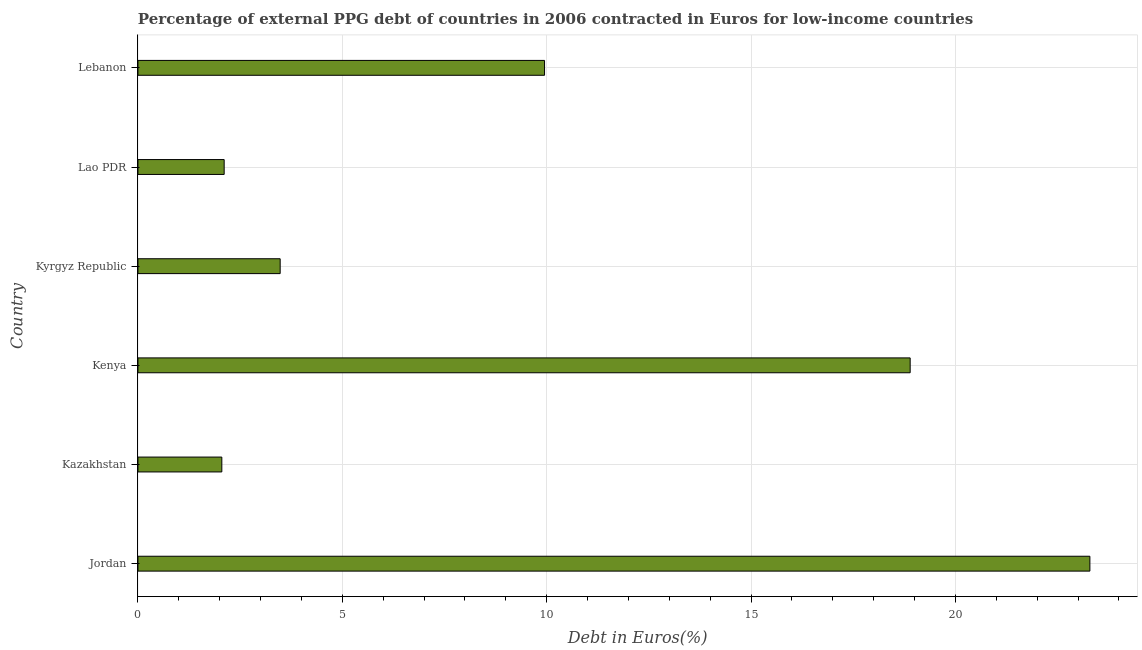Does the graph contain any zero values?
Provide a short and direct response. No. Does the graph contain grids?
Your answer should be compact. Yes. What is the title of the graph?
Keep it short and to the point. Percentage of external PPG debt of countries in 2006 contracted in Euros for low-income countries. What is the label or title of the X-axis?
Provide a succinct answer. Debt in Euros(%). What is the label or title of the Y-axis?
Make the answer very short. Country. What is the currency composition of ppg debt in Kenya?
Your response must be concise. 18.89. Across all countries, what is the maximum currency composition of ppg debt?
Offer a very short reply. 23.29. Across all countries, what is the minimum currency composition of ppg debt?
Offer a terse response. 2.05. In which country was the currency composition of ppg debt maximum?
Give a very brief answer. Jordan. In which country was the currency composition of ppg debt minimum?
Give a very brief answer. Kazakhstan. What is the sum of the currency composition of ppg debt?
Provide a short and direct response. 59.77. What is the difference between the currency composition of ppg debt in Jordan and Kyrgyz Republic?
Provide a short and direct response. 19.81. What is the average currency composition of ppg debt per country?
Make the answer very short. 9.96. What is the median currency composition of ppg debt?
Your answer should be very brief. 6.71. In how many countries, is the currency composition of ppg debt greater than 8 %?
Your answer should be very brief. 3. What is the ratio of the currency composition of ppg debt in Jordan to that in Kyrgyz Republic?
Provide a succinct answer. 6.69. Is the currency composition of ppg debt in Jordan less than that in Kyrgyz Republic?
Offer a terse response. No. What is the difference between the highest and the second highest currency composition of ppg debt?
Your response must be concise. 4.4. What is the difference between the highest and the lowest currency composition of ppg debt?
Offer a terse response. 21.24. Are all the bars in the graph horizontal?
Offer a very short reply. Yes. Are the values on the major ticks of X-axis written in scientific E-notation?
Offer a very short reply. No. What is the Debt in Euros(%) in Jordan?
Give a very brief answer. 23.29. What is the Debt in Euros(%) of Kazakhstan?
Offer a very short reply. 2.05. What is the Debt in Euros(%) in Kenya?
Your response must be concise. 18.89. What is the Debt in Euros(%) in Kyrgyz Republic?
Keep it short and to the point. 3.48. What is the Debt in Euros(%) in Lao PDR?
Your answer should be compact. 2.11. What is the Debt in Euros(%) of Lebanon?
Your answer should be compact. 9.95. What is the difference between the Debt in Euros(%) in Jordan and Kazakhstan?
Provide a succinct answer. 21.24. What is the difference between the Debt in Euros(%) in Jordan and Kenya?
Give a very brief answer. 4.4. What is the difference between the Debt in Euros(%) in Jordan and Kyrgyz Republic?
Keep it short and to the point. 19.81. What is the difference between the Debt in Euros(%) in Jordan and Lao PDR?
Keep it short and to the point. 21.18. What is the difference between the Debt in Euros(%) in Jordan and Lebanon?
Offer a very short reply. 13.34. What is the difference between the Debt in Euros(%) in Kazakhstan and Kenya?
Keep it short and to the point. -16.84. What is the difference between the Debt in Euros(%) in Kazakhstan and Kyrgyz Republic?
Your answer should be compact. -1.43. What is the difference between the Debt in Euros(%) in Kazakhstan and Lao PDR?
Make the answer very short. -0.06. What is the difference between the Debt in Euros(%) in Kazakhstan and Lebanon?
Keep it short and to the point. -7.9. What is the difference between the Debt in Euros(%) in Kenya and Kyrgyz Republic?
Your answer should be compact. 15.41. What is the difference between the Debt in Euros(%) in Kenya and Lao PDR?
Provide a short and direct response. 16.78. What is the difference between the Debt in Euros(%) in Kenya and Lebanon?
Give a very brief answer. 8.94. What is the difference between the Debt in Euros(%) in Kyrgyz Republic and Lao PDR?
Provide a short and direct response. 1.37. What is the difference between the Debt in Euros(%) in Kyrgyz Republic and Lebanon?
Provide a short and direct response. -6.47. What is the difference between the Debt in Euros(%) in Lao PDR and Lebanon?
Offer a very short reply. -7.84. What is the ratio of the Debt in Euros(%) in Jordan to that in Kazakhstan?
Your response must be concise. 11.35. What is the ratio of the Debt in Euros(%) in Jordan to that in Kenya?
Make the answer very short. 1.23. What is the ratio of the Debt in Euros(%) in Jordan to that in Kyrgyz Republic?
Keep it short and to the point. 6.69. What is the ratio of the Debt in Euros(%) in Jordan to that in Lao PDR?
Offer a terse response. 11.04. What is the ratio of the Debt in Euros(%) in Jordan to that in Lebanon?
Give a very brief answer. 2.34. What is the ratio of the Debt in Euros(%) in Kazakhstan to that in Kenya?
Provide a short and direct response. 0.11. What is the ratio of the Debt in Euros(%) in Kazakhstan to that in Kyrgyz Republic?
Offer a very short reply. 0.59. What is the ratio of the Debt in Euros(%) in Kazakhstan to that in Lebanon?
Provide a succinct answer. 0.21. What is the ratio of the Debt in Euros(%) in Kenya to that in Kyrgyz Republic?
Make the answer very short. 5.43. What is the ratio of the Debt in Euros(%) in Kenya to that in Lao PDR?
Ensure brevity in your answer.  8.96. What is the ratio of the Debt in Euros(%) in Kenya to that in Lebanon?
Offer a very short reply. 1.9. What is the ratio of the Debt in Euros(%) in Kyrgyz Republic to that in Lao PDR?
Keep it short and to the point. 1.65. What is the ratio of the Debt in Euros(%) in Kyrgyz Republic to that in Lebanon?
Provide a succinct answer. 0.35. What is the ratio of the Debt in Euros(%) in Lao PDR to that in Lebanon?
Make the answer very short. 0.21. 